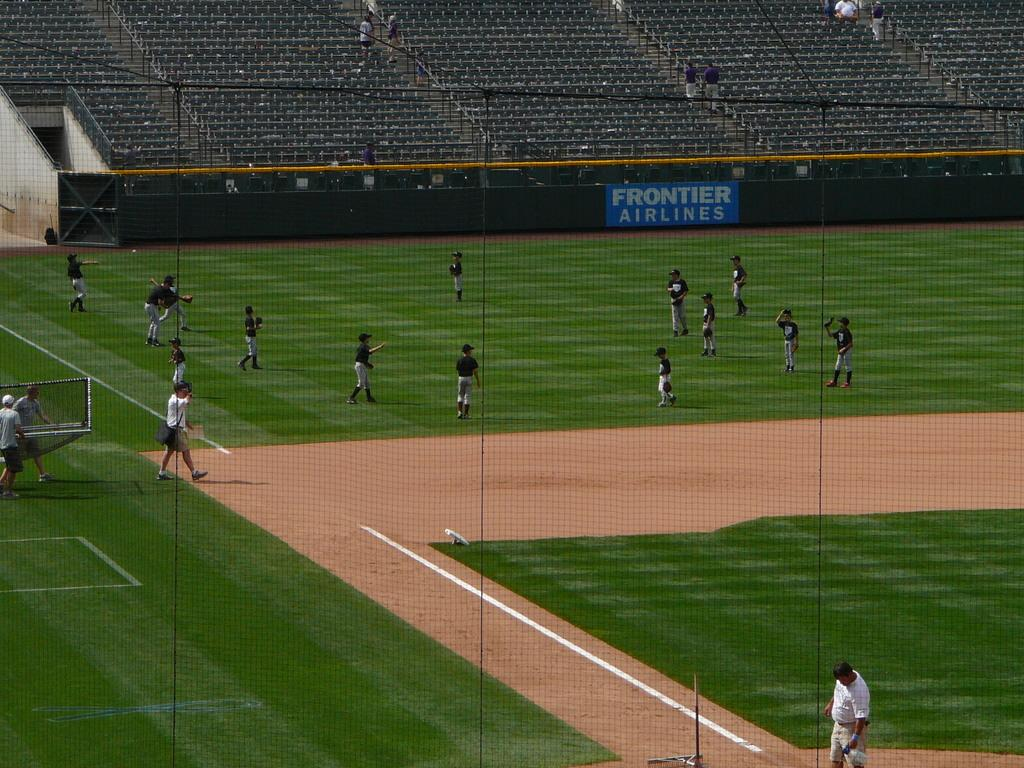<image>
Summarize the visual content of the image. The baseball team practicing on a field sponsored by Frontier Airlines. 